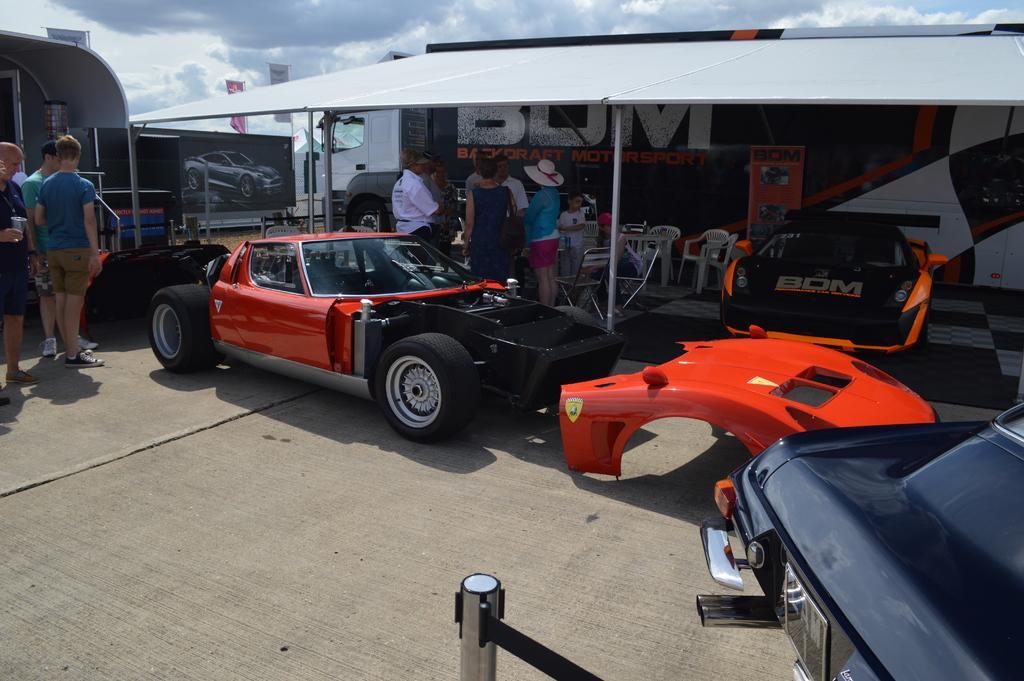Could you give a brief overview of what you see in this image? In this image we can see sports cars and there are people standing. We can see chairs. In the background there is a bus and a shed. At the top there is sky and we can see boards. 